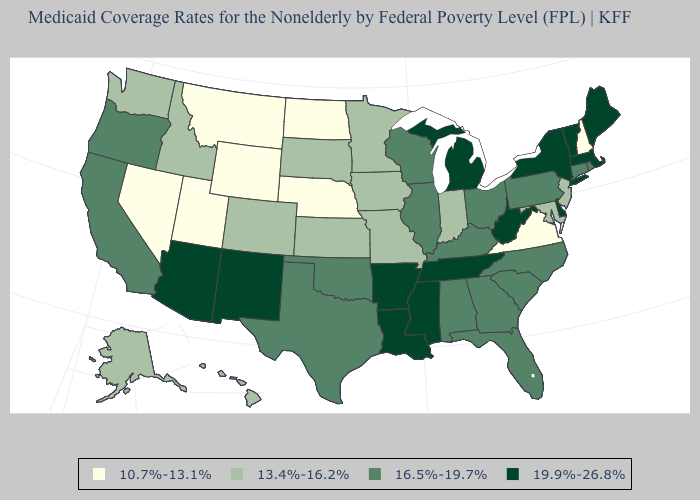What is the value of New Mexico?
Answer briefly. 19.9%-26.8%. Does the map have missing data?
Short answer required. No. What is the value of Maryland?
Quick response, please. 13.4%-16.2%. Among the states that border Mississippi , which have the lowest value?
Concise answer only. Alabama. Does Florida have the highest value in the South?
Concise answer only. No. Name the states that have a value in the range 13.4%-16.2%?
Keep it brief. Alaska, Colorado, Hawaii, Idaho, Indiana, Iowa, Kansas, Maryland, Minnesota, Missouri, New Jersey, South Dakota, Washington. Does Nebraska have the lowest value in the USA?
Be succinct. Yes. Which states have the lowest value in the MidWest?
Answer briefly. Nebraska, North Dakota. Does Florida have a higher value than Connecticut?
Concise answer only. No. Name the states that have a value in the range 10.7%-13.1%?
Be succinct. Montana, Nebraska, Nevada, New Hampshire, North Dakota, Utah, Virginia, Wyoming. Which states hav the highest value in the MidWest?
Give a very brief answer. Michigan. Name the states that have a value in the range 19.9%-26.8%?
Answer briefly. Arizona, Arkansas, Delaware, Louisiana, Maine, Massachusetts, Michigan, Mississippi, New Mexico, New York, Tennessee, Vermont, West Virginia. Does North Dakota have a lower value than Nebraska?
Concise answer only. No. 